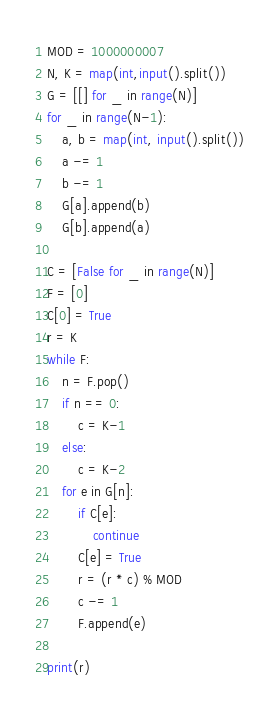<code> <loc_0><loc_0><loc_500><loc_500><_Python_>MOD = 1000000007
N, K = map(int,input().split())
G = [[] for _ in range(N)]
for _ in range(N-1):
    a, b = map(int, input().split())
    a -= 1
    b -= 1
    G[a].append(b)
    G[b].append(a)

C = [False for _ in range(N)]
F = [0]
C[0] = True
r = K
while F:
    n = F.pop()
    if n == 0:
        c = K-1
    else:
        c = K-2
    for e in G[n]:
        if C[e]:
            continue
        C[e] = True
        r = (r * c) % MOD
        c -= 1
        F.append(e)

print(r)</code> 